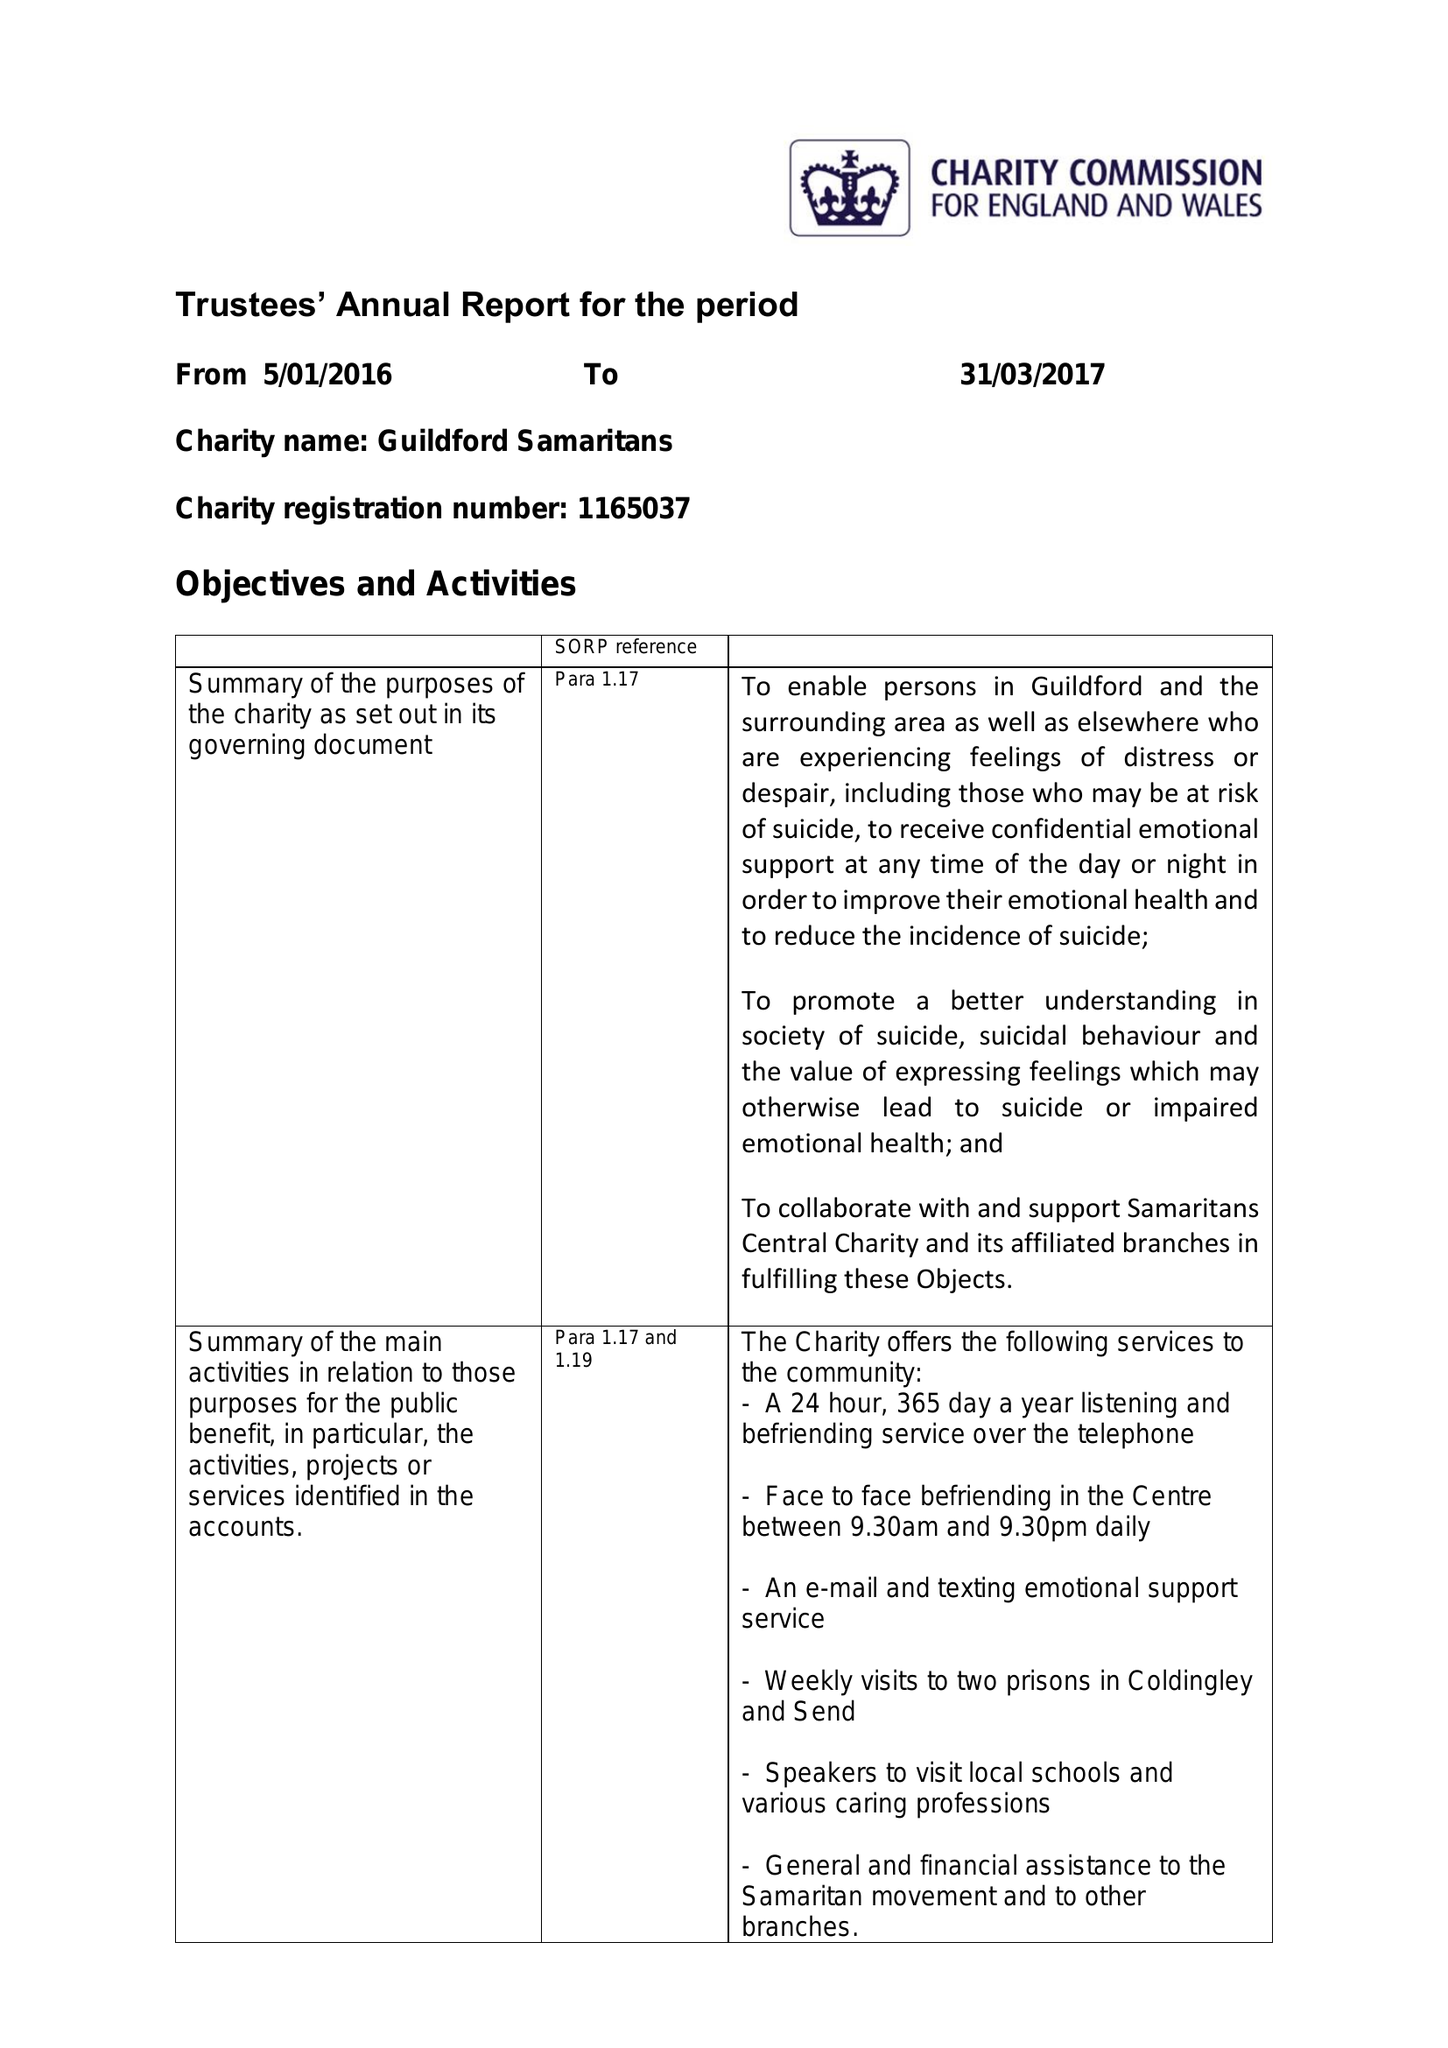What is the value for the address__postcode?
Answer the question using a single word or phrase. GU1 4RD 